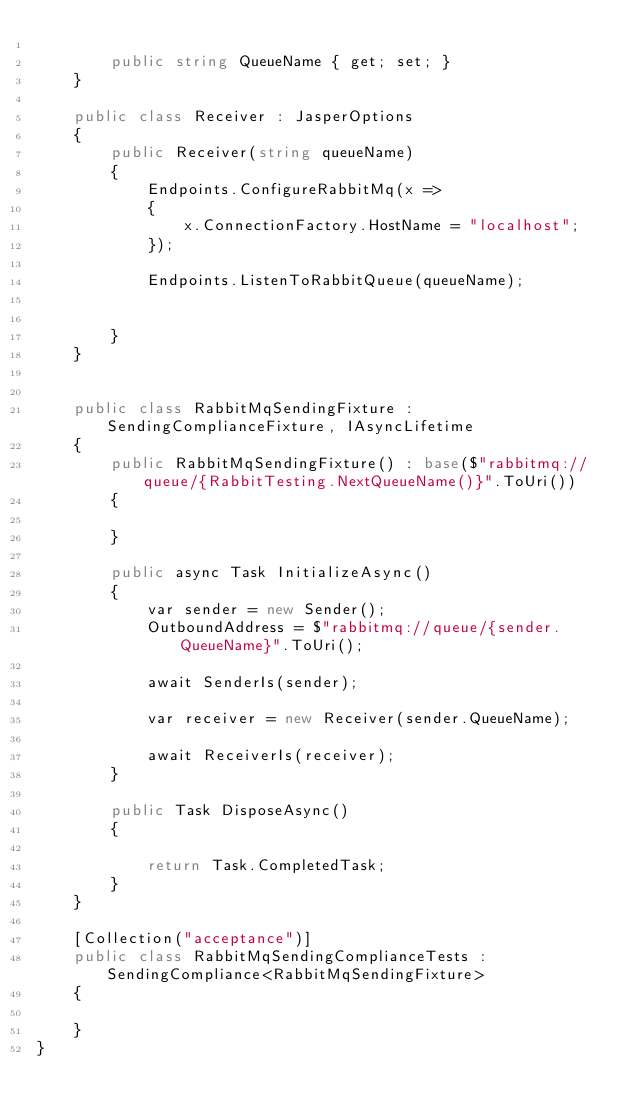Convert code to text. <code><loc_0><loc_0><loc_500><loc_500><_C#_>
        public string QueueName { get; set; }
    }

    public class Receiver : JasperOptions
    {
        public Receiver(string queueName)
        {
            Endpoints.ConfigureRabbitMq(x =>
            {
                x.ConnectionFactory.HostName = "localhost";
            });

            Endpoints.ListenToRabbitQueue(queueName);


        }
    }


    public class RabbitMqSendingFixture : SendingComplianceFixture, IAsyncLifetime
    {
        public RabbitMqSendingFixture() : base($"rabbitmq://queue/{RabbitTesting.NextQueueName()}".ToUri())
        {

        }

        public async Task InitializeAsync()
        {
            var sender = new Sender();
            OutboundAddress = $"rabbitmq://queue/{sender.QueueName}".ToUri();

            await SenderIs(sender);

            var receiver = new Receiver(sender.QueueName);

            await ReceiverIs(receiver);
        }

        public Task DisposeAsync()
        {

            return Task.CompletedTask;
        }
    }

    [Collection("acceptance")]
    public class RabbitMqSendingComplianceTests : SendingCompliance<RabbitMqSendingFixture>
    {

    }
}
</code> 